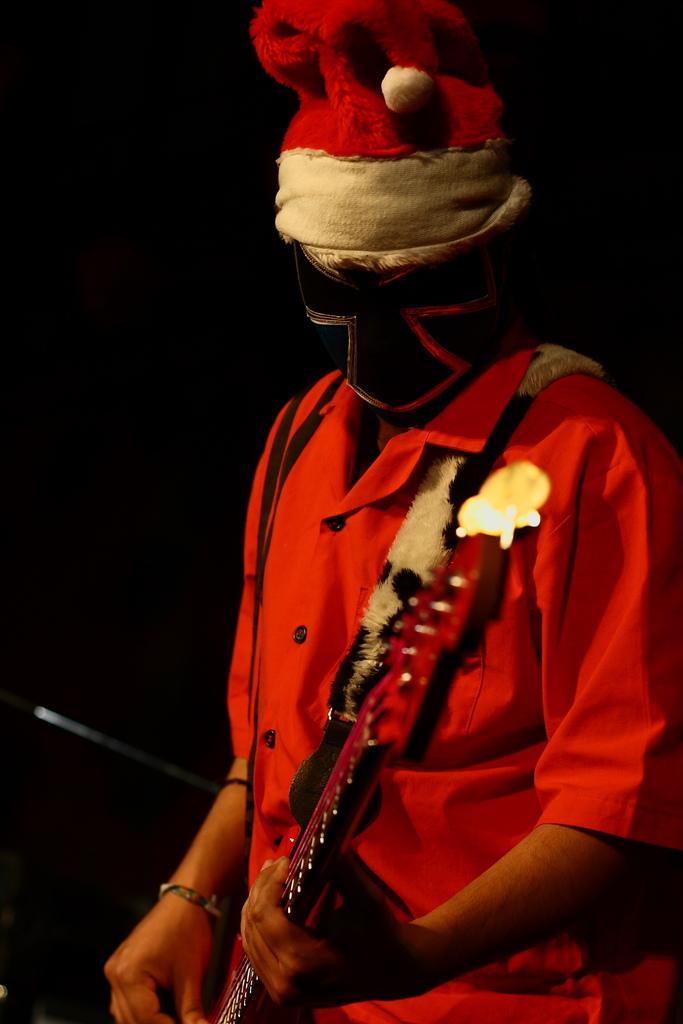What is the main subject of the image? The main subject of the image is a man. Can you describe what the man is wearing? The man is wearing a mask and a red color shirt. What object is the man holding in the image? The man is holding a guitar. How many children are visible in the image? There are no children present in the image; it features a man holding a guitar. What type of metal is used to make the guitar in the image? The image does not provide information about the type of metal used to make the guitar. 